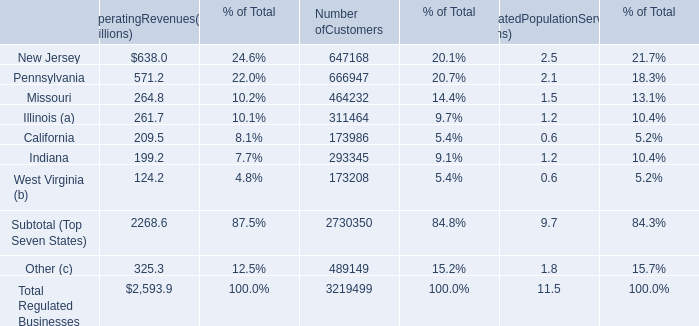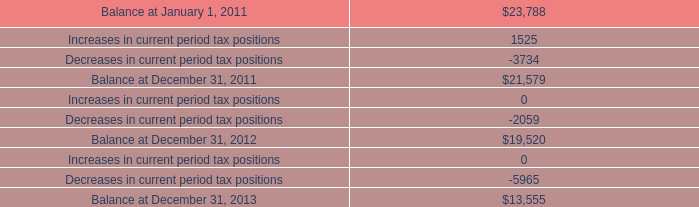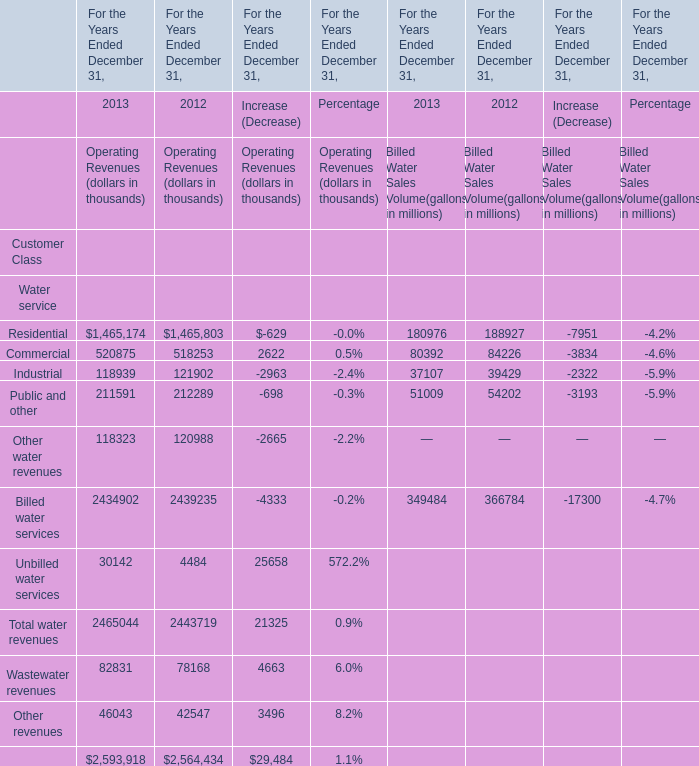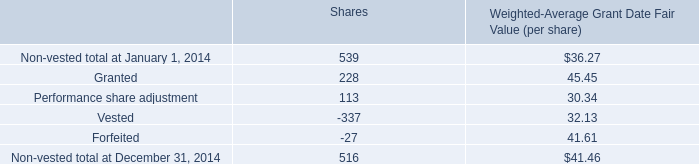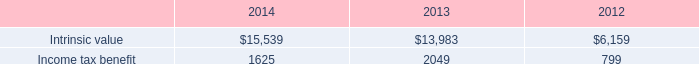What is the average amount of Decreases in current period tax positions, and New Jersey of Number ofCustomers ? 
Computations: ((2059.0 + 647168.0) / 2)
Answer: 324613.5. 